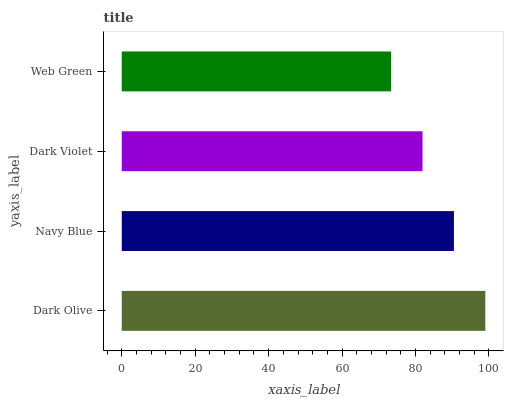Is Web Green the minimum?
Answer yes or no. Yes. Is Dark Olive the maximum?
Answer yes or no. Yes. Is Navy Blue the minimum?
Answer yes or no. No. Is Navy Blue the maximum?
Answer yes or no. No. Is Dark Olive greater than Navy Blue?
Answer yes or no. Yes. Is Navy Blue less than Dark Olive?
Answer yes or no. Yes. Is Navy Blue greater than Dark Olive?
Answer yes or no. No. Is Dark Olive less than Navy Blue?
Answer yes or no. No. Is Navy Blue the high median?
Answer yes or no. Yes. Is Dark Violet the low median?
Answer yes or no. Yes. Is Dark Violet the high median?
Answer yes or no. No. Is Navy Blue the low median?
Answer yes or no. No. 